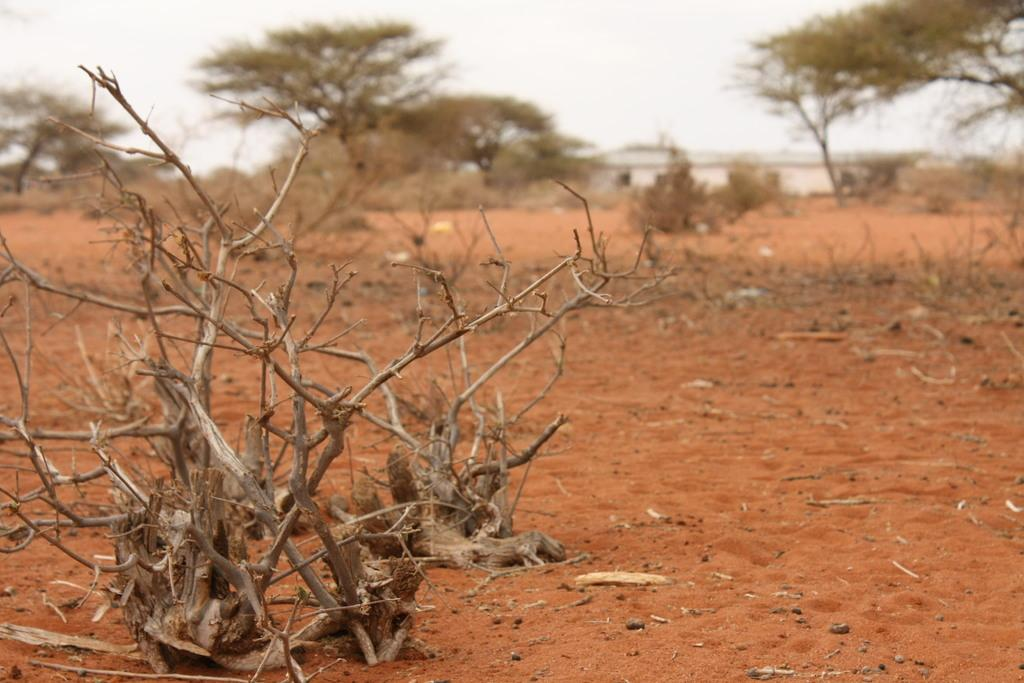What type of vegetation can be seen in the image? There are trees in the image. What other objects related to trees can be seen in the image? There are twigs in the image. What is visible at the top of the image? The sky is visible at the top of the image. What is visible at the bottom of the image? The ground is visible at the bottom of the image. What type of muscle is visible in the image? There is no muscle visible in the image; it features trees, twigs, the sky, and the ground. 